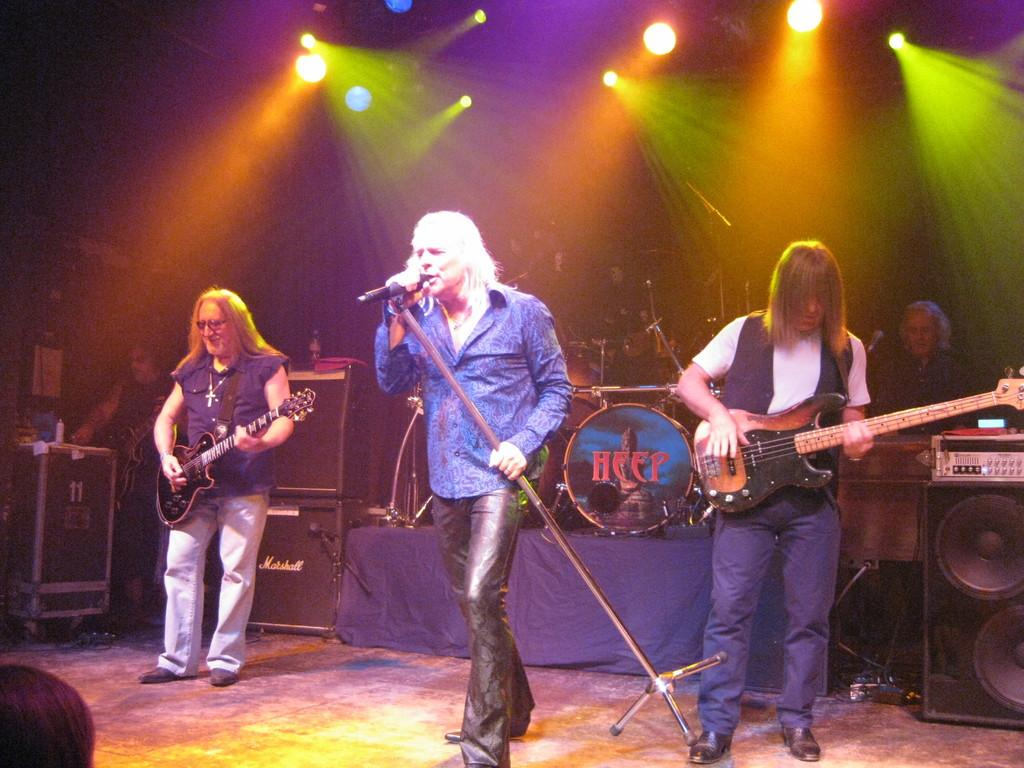How many people are in the image? There are three persons standing on the floor. What are two of the persons doing? Two of the persons are playing guitar. What is the third person doing? One person is singing on a microphone. What else can be seen in the image besides the people? There are musical instruments and lights visible. What type of glove is being used to play the guitar in the image? There is no glove visible in the image; the guitar is being played with bare hands. 